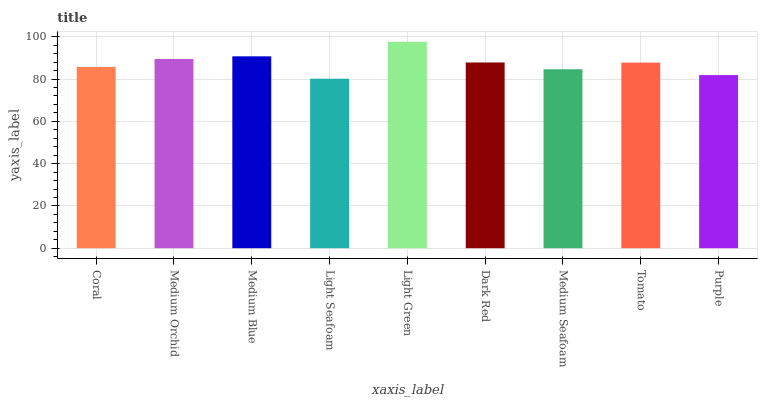Is Light Seafoam the minimum?
Answer yes or no. Yes. Is Light Green the maximum?
Answer yes or no. Yes. Is Medium Orchid the minimum?
Answer yes or no. No. Is Medium Orchid the maximum?
Answer yes or no. No. Is Medium Orchid greater than Coral?
Answer yes or no. Yes. Is Coral less than Medium Orchid?
Answer yes or no. Yes. Is Coral greater than Medium Orchid?
Answer yes or no. No. Is Medium Orchid less than Coral?
Answer yes or no. No. Is Tomato the high median?
Answer yes or no. Yes. Is Tomato the low median?
Answer yes or no. Yes. Is Medium Orchid the high median?
Answer yes or no. No. Is Coral the low median?
Answer yes or no. No. 